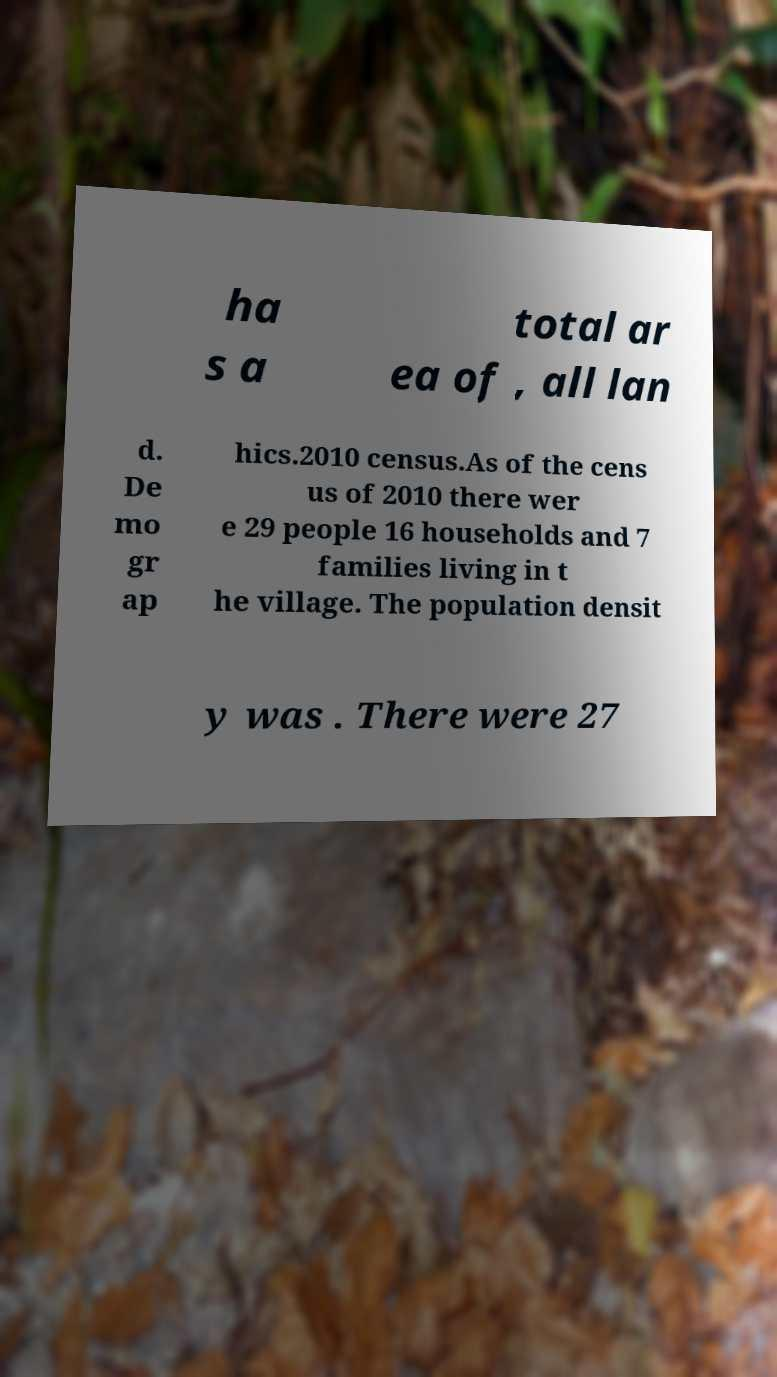Can you accurately transcribe the text from the provided image for me? ha s a total ar ea of , all lan d. De mo gr ap hics.2010 census.As of the cens us of 2010 there wer e 29 people 16 households and 7 families living in t he village. The population densit y was . There were 27 